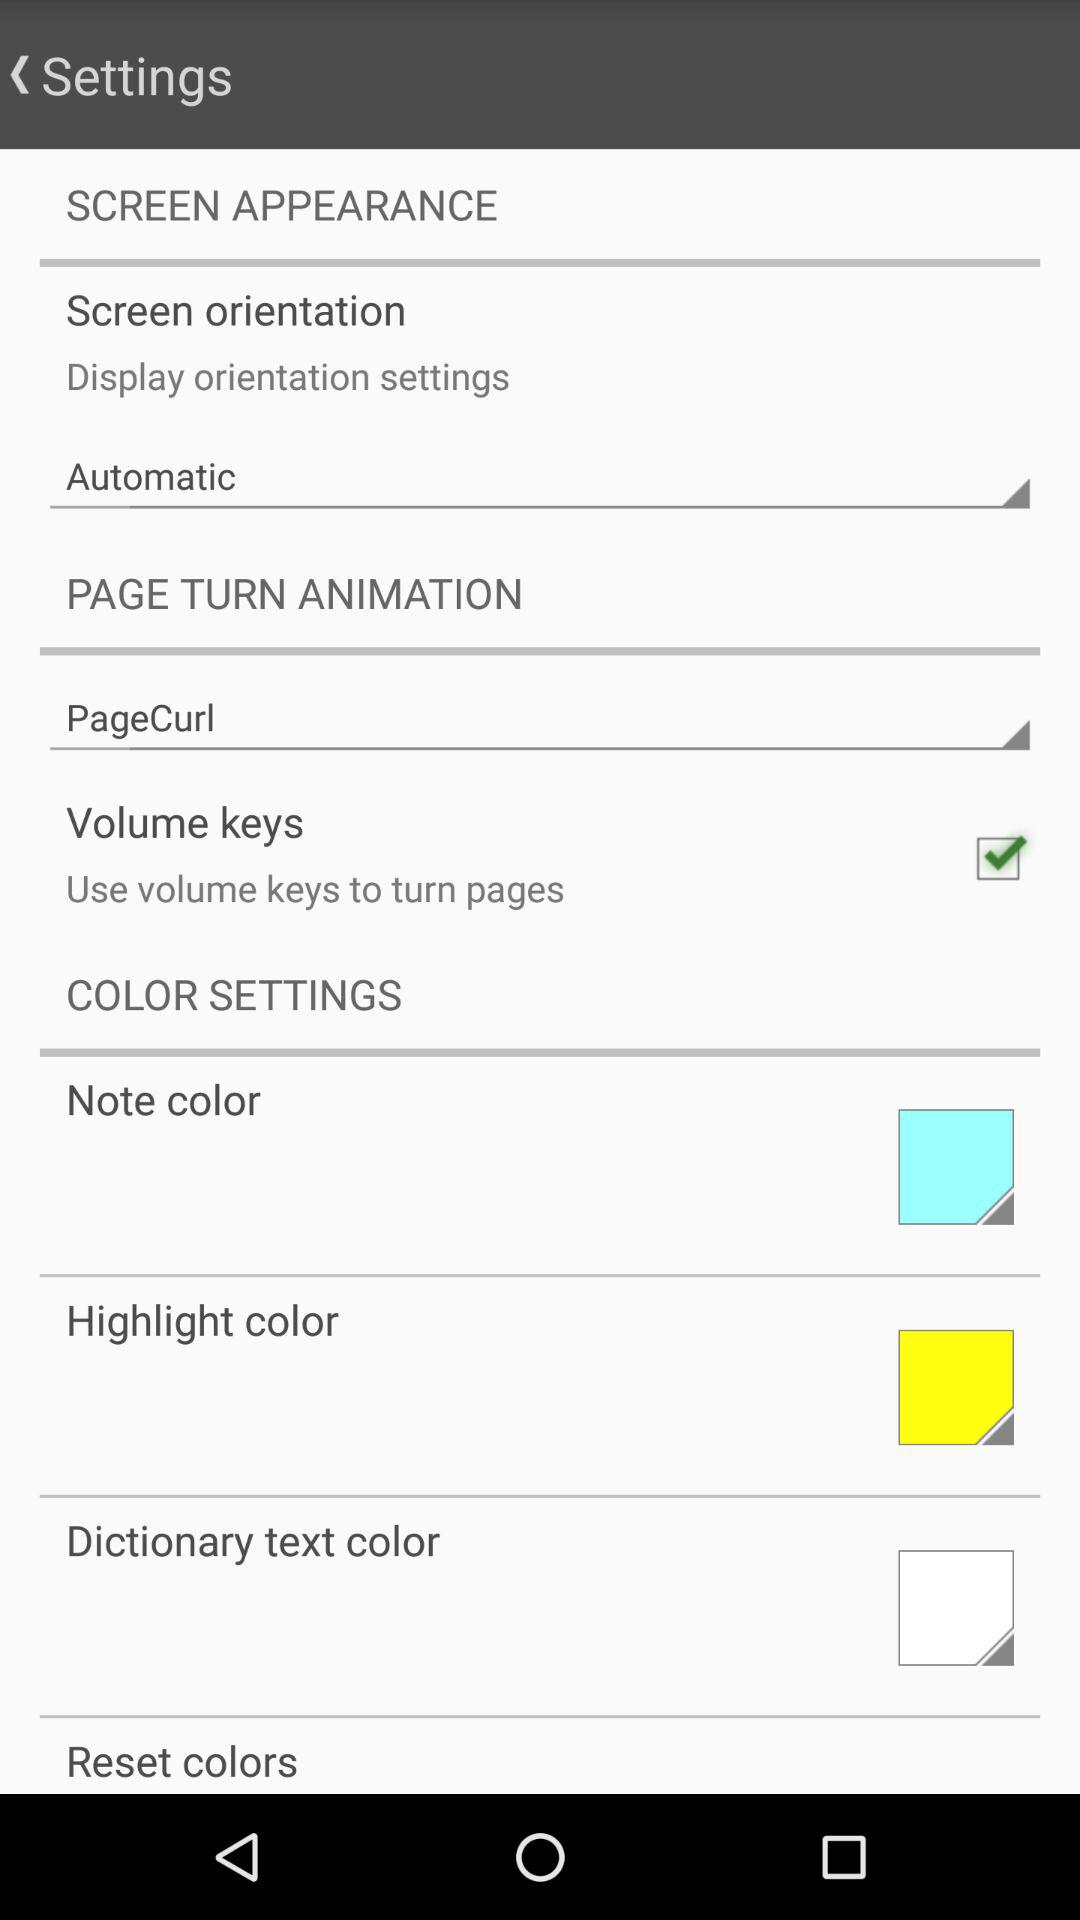What are the options available in the color settings? The available options are "Note color", "Highlight color", "Dictionary text color" and "Reset colors". 